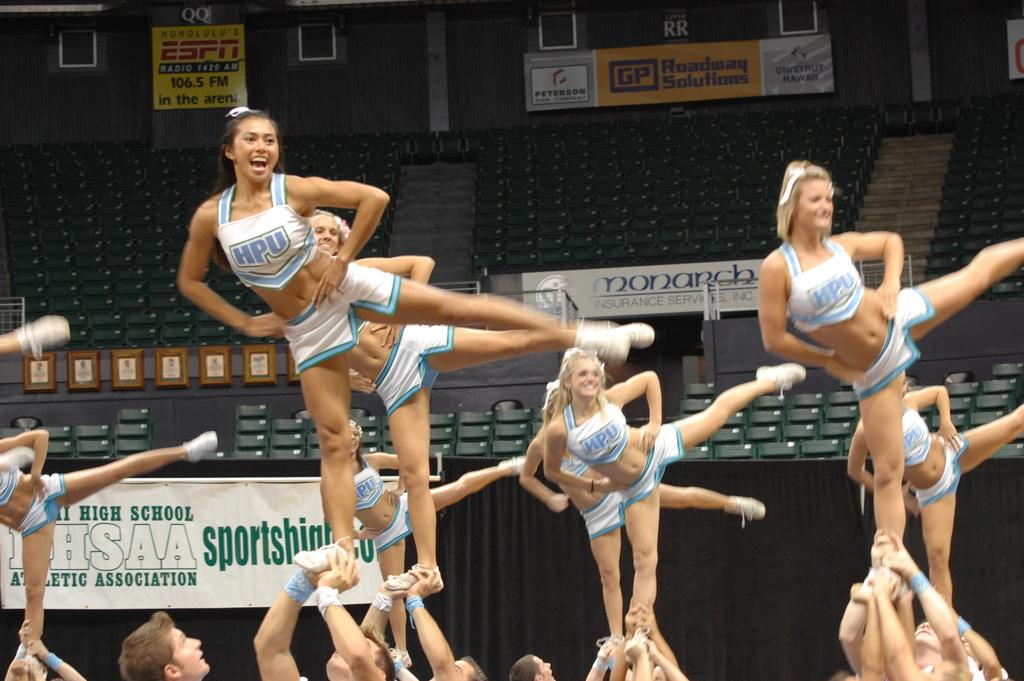What is espn's fm station number at this arena?
Keep it short and to the point. 106.5. 